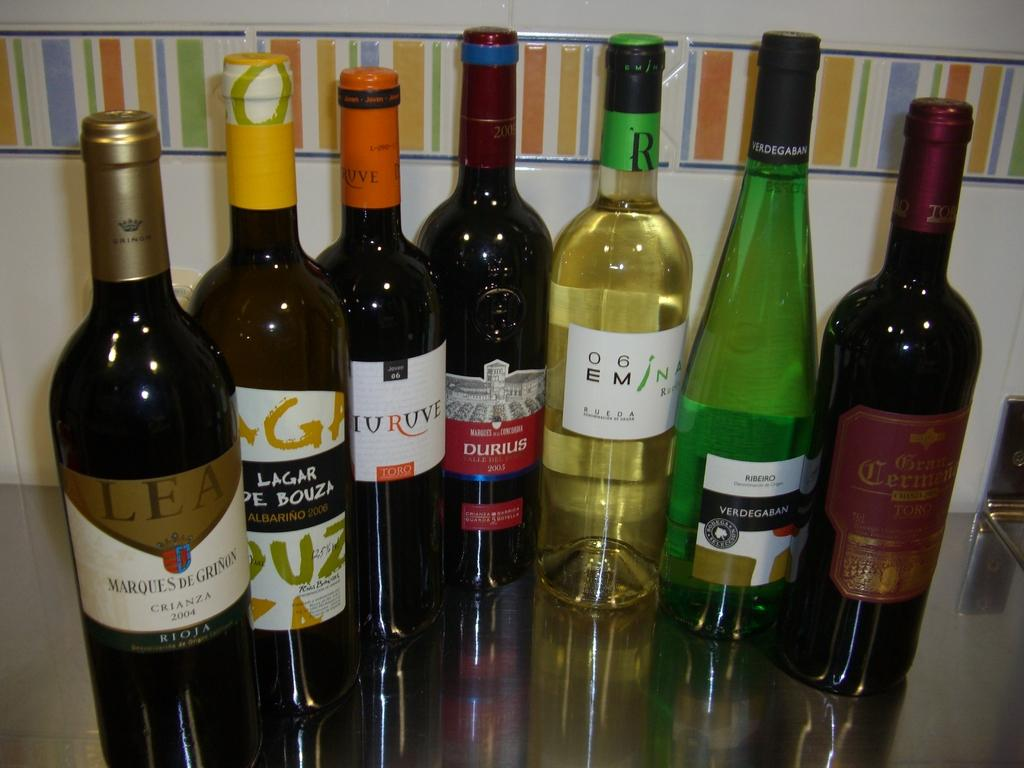What objects can be seen in the image? There are bottles in the image. What is unique about the bottles? There is writing on the bottles. Can you see a frog jumping out of the letters in the image? There is no frog or letters present in the image; it only features bottles with writing on them. 